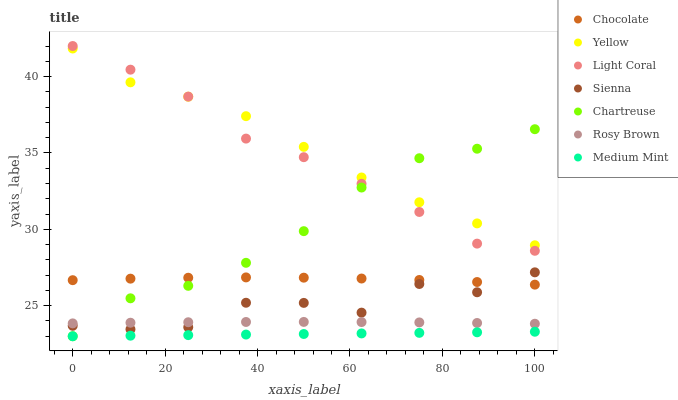Does Medium Mint have the minimum area under the curve?
Answer yes or no. Yes. Does Yellow have the maximum area under the curve?
Answer yes or no. Yes. Does Sienna have the minimum area under the curve?
Answer yes or no. No. Does Sienna have the maximum area under the curve?
Answer yes or no. No. Is Medium Mint the smoothest?
Answer yes or no. Yes. Is Sienna the roughest?
Answer yes or no. Yes. Is Rosy Brown the smoothest?
Answer yes or no. No. Is Rosy Brown the roughest?
Answer yes or no. No. Does Medium Mint have the lowest value?
Answer yes or no. Yes. Does Sienna have the lowest value?
Answer yes or no. No. Does Light Coral have the highest value?
Answer yes or no. Yes. Does Sienna have the highest value?
Answer yes or no. No. Is Chocolate less than Yellow?
Answer yes or no. Yes. Is Yellow greater than Chocolate?
Answer yes or no. Yes. Does Rosy Brown intersect Chartreuse?
Answer yes or no. Yes. Is Rosy Brown less than Chartreuse?
Answer yes or no. No. Is Rosy Brown greater than Chartreuse?
Answer yes or no. No. Does Chocolate intersect Yellow?
Answer yes or no. No. 